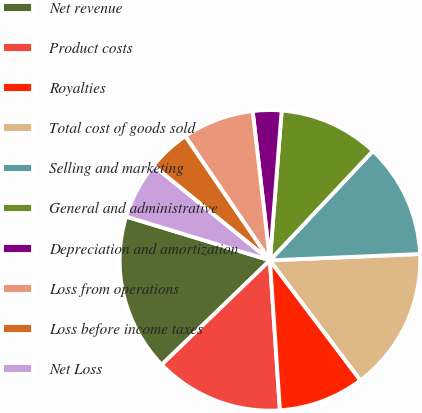<chart> <loc_0><loc_0><loc_500><loc_500><pie_chart><fcel>Net revenue<fcel>Product costs<fcel>Royalties<fcel>Total cost of goods sold<fcel>Selling and marketing<fcel>General and administrative<fcel>Depreciation and amortization<fcel>Loss from operations<fcel>Loss before income taxes<fcel>Net Loss<nl><fcel>16.92%<fcel>13.85%<fcel>9.23%<fcel>15.38%<fcel>12.31%<fcel>10.77%<fcel>3.08%<fcel>7.69%<fcel>4.62%<fcel>6.15%<nl></chart> 